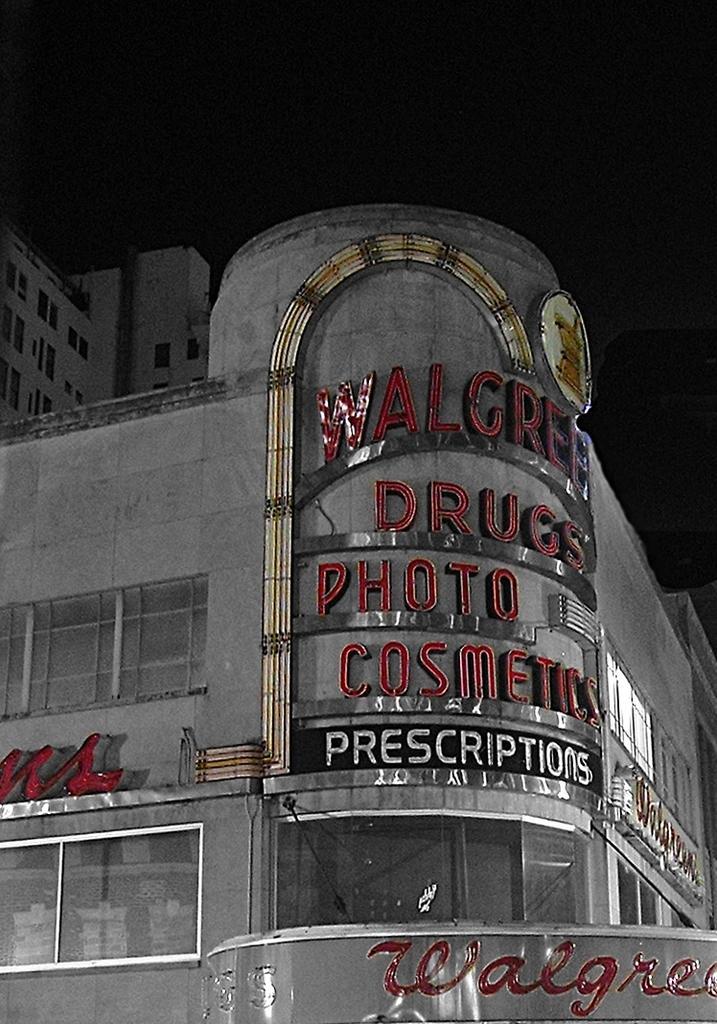In one or two sentences, can you explain what this image depicts? In front of the picture, we see a building in grey color. We see the boards in black and text written in red color. It has windows. In the background, we see a building in white color. At the top, it is black in color. This picture is clicked in the dark. 